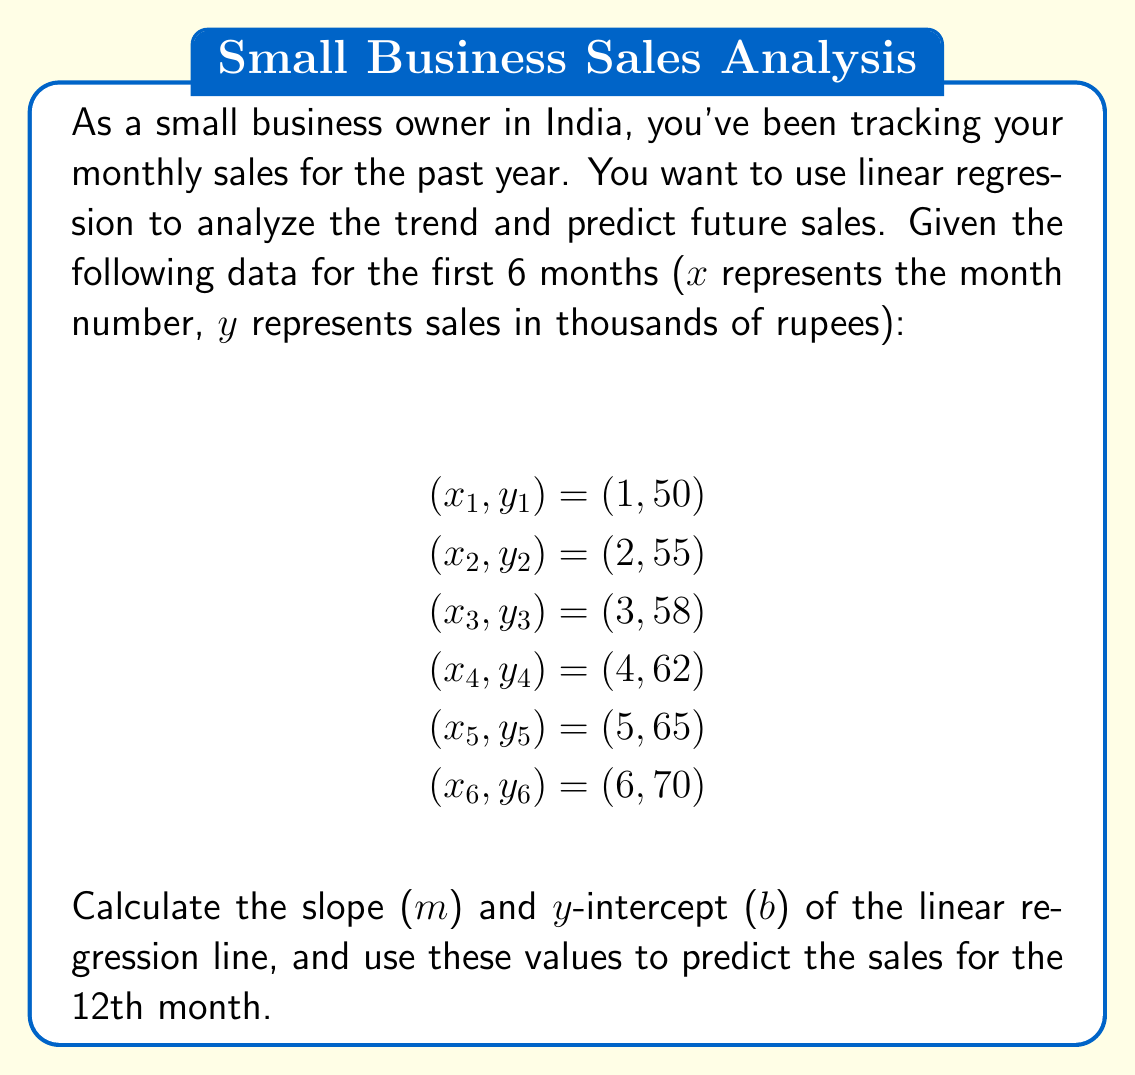Help me with this question. To solve this problem, we'll use the linear regression formula:

$$y = mx + b$$

Where m is the slope and b is the y-intercept. We'll calculate these using the following formulas:

$$m = \frac{n\sum{xy} - \sum{x}\sum{y}}{n\sum{x^2} - (\sum{x})^2}$$

$$b = \frac{\sum{y} - m\sum{x}}{n}$$

Step 1: Calculate the necessary sums:
$$\sum{x} = 1 + 2 + 3 + 4 + 5 + 6 = 21$$
$$\sum{y} = 50 + 55 + 58 + 62 + 65 + 70 = 360$$
$$\sum{xy} = 1(50) + 2(55) + 3(58) + 4(62) + 5(65) + 6(70) = 1420$$
$$\sum{x^2} = 1^2 + 2^2 + 3^2 + 4^2 + 5^2 + 6^2 = 91$$
$$n = 6$$ (number of data points)

Step 2: Calculate the slope (m):
$$m = \frac{6(1420) - 21(360)}{6(91) - 21^2} = \frac{8520 - 7560}{546 - 441} = \frac{960}{105} = 9.14285714$$

Step 3: Calculate the y-intercept (b):
$$b = \frac{360 - 9.14285714(21)}{6} = \frac{360 - 192}{6} = 28$$

Step 4: Write the equation of the linear regression line:
$$y = 9.14285714x + 28$$

Step 5: Predict the sales for the 12th month by plugging in x = 12:
$$y = 9.14285714(12) + 28 = 109.71428568 + 28 = 137.71428568$$

Therefore, the predicted sales for the 12th month is approximately 137,714 rupees.
Answer: Slope (m) = 9.14285714
Y-intercept (b) = 28
Predicted sales for the 12th month ≈ 137,714 rupees 